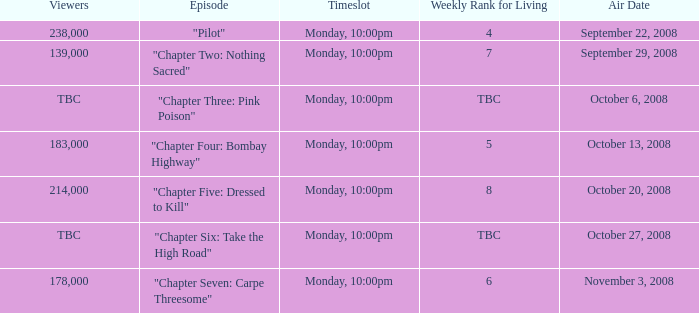What is the episode with the 183,000 viewers? "Chapter Four: Bombay Highway". 